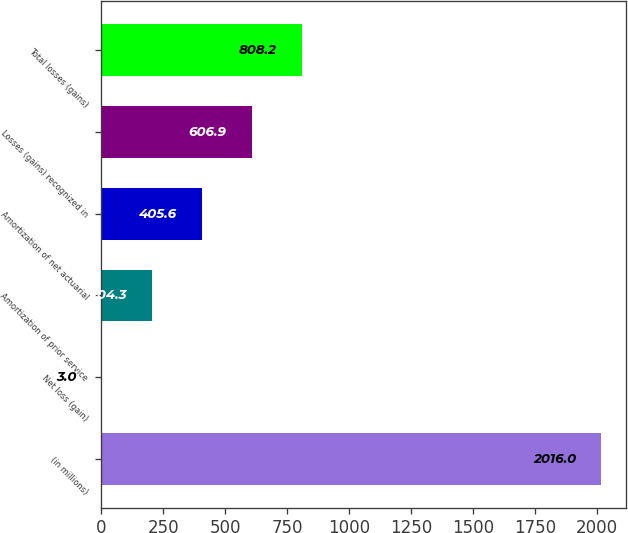Convert chart. <chart><loc_0><loc_0><loc_500><loc_500><bar_chart><fcel>(in millions)<fcel>Net loss (gain)<fcel>Amortization of prior service<fcel>Amortization of net actuarial<fcel>Losses (gains) recognized in<fcel>Total losses (gains)<nl><fcel>2016<fcel>3<fcel>204.3<fcel>405.6<fcel>606.9<fcel>808.2<nl></chart> 